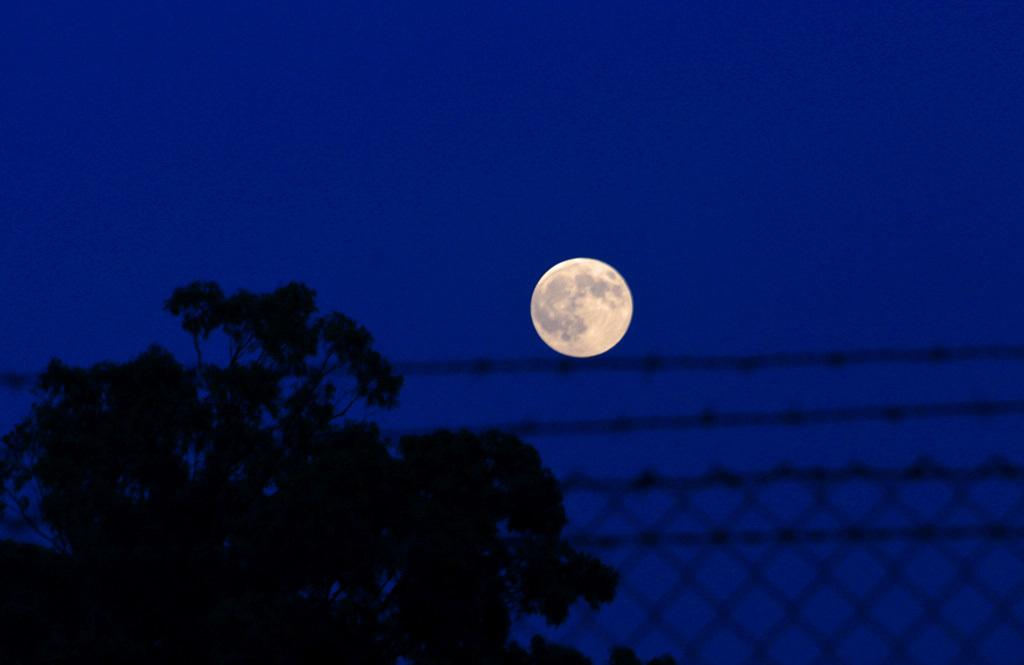What type of structure can be seen in the image? There is a mesh and fencing in the image. What natural element is present in the image? There is a tree in the image. What can be seen in the background of the image? The sky is visible in the background of the image. What celestial body is visible in the sky? The moon is visible in the sky. What type of bomb is being diffused by the father in the image? There is no father or bomb present in the image. What is the middle element in the image? The image does not have a specific "middle" element; it contains a mesh, fencing, a tree, and the sky. 